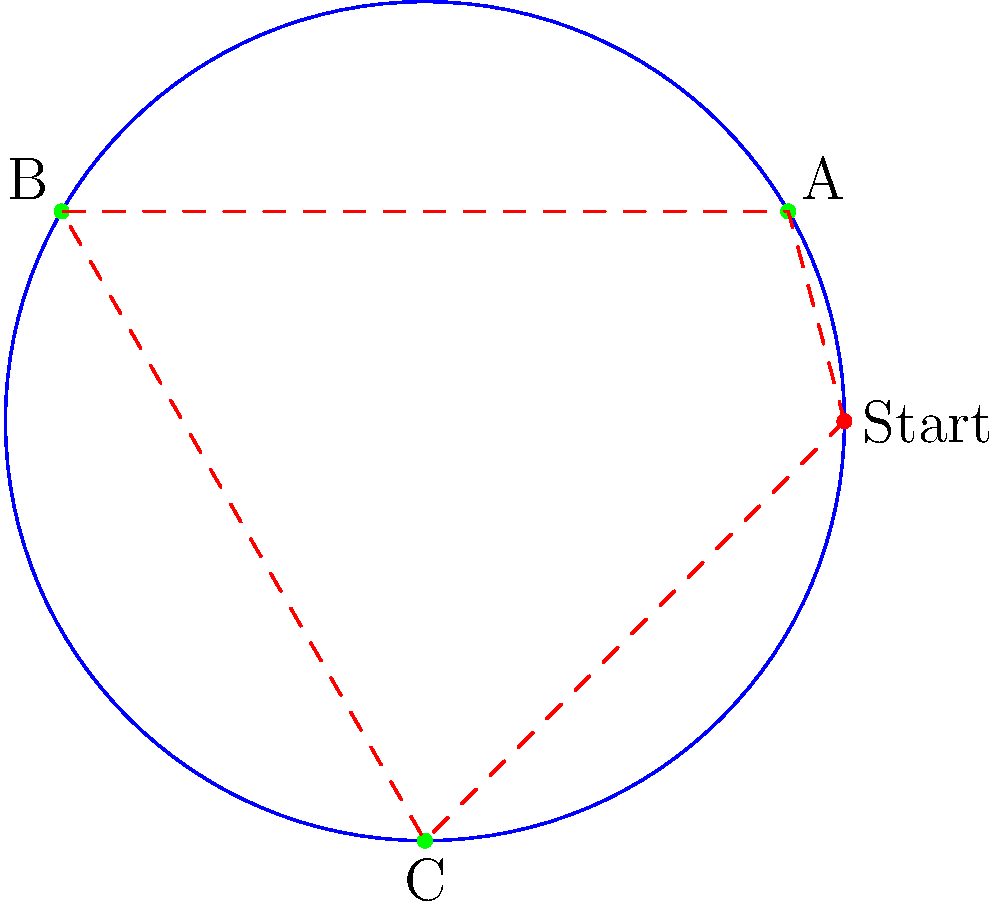A boom lift needs to reach three points (A, B, and C) on a circular construction site with a radius of 10 meters. The boom lift starts at the edge of the site (10, 0) in polar coordinates. Point A is located at $(60°, 10)$, point B at $(120°, 10)$, and point C at $(270°, 10)$ in polar coordinates. Calculate the total distance the boom lift needs to travel to reach all points and return to the starting position, following the optimal path shown in the diagram. To solve this problem, we need to calculate the distances between each point and sum them up. We'll use the formula for the distance between two points in polar coordinates:

$d = \sqrt{r_1^2 + r_2^2 - 2r_1r_2\cos(\theta_2 - \theta_1)}$

Step 1: Calculate the distance from Start to A
$d_{SA} = \sqrt{10^2 + 10^2 - 2(10)(10)\cos(60° - 0°)} = \sqrt{200 - 200\cos(60°)} \approx 10$ m

Step 2: Calculate the distance from A to B
$d_{AB} = \sqrt{10^2 + 10^2 - 2(10)(10)\cos(120° - 60°)} = \sqrt{200 - 200\cos(60°)} \approx 10$ m

Step 3: Calculate the distance from B to C
$d_{BC} = \sqrt{10^2 + 10^2 - 2(10)(10)\cos(270° - 120°)} = \sqrt{200 - 200\cos(150°)} \approx 17.32$ m

Step 4: Calculate the distance from C back to Start
$d_{CS} = \sqrt{10^2 + 10^2 - 2(10)(10)\cos(0° - 270°)} = \sqrt{200 - 200\cos(90°)} = 10\sqrt{2} \approx 14.14$ m

Step 5: Sum up all the distances
Total distance = $d_{SA} + d_{AB} + d_{BC} + d_{CS}$
$\approx 10 + 10 + 17.32 + 14.14 = 51.46$ m

Therefore, the total distance the boom lift needs to travel is approximately 51.46 meters.
Answer: 51.46 meters 